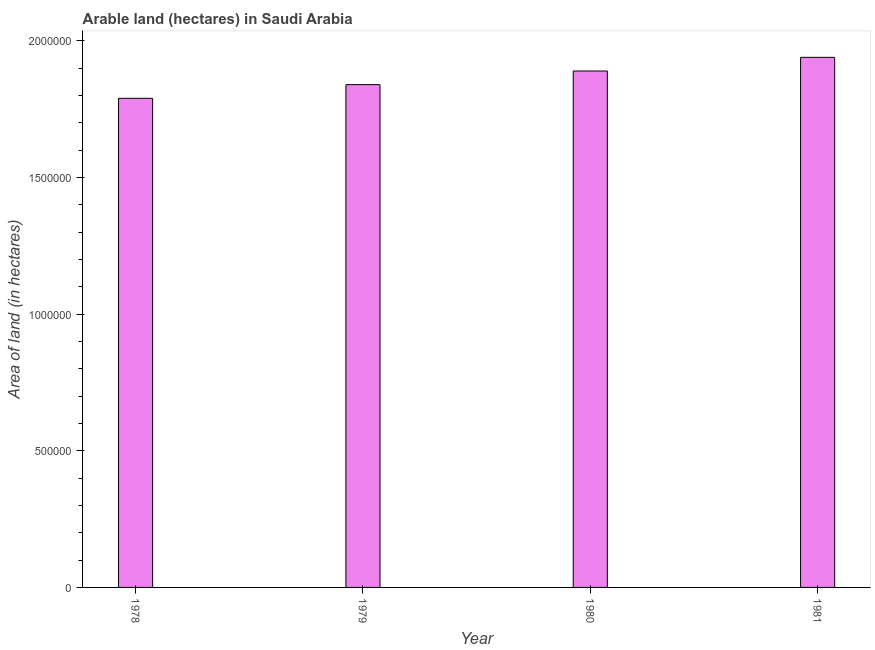Does the graph contain any zero values?
Offer a terse response. No. Does the graph contain grids?
Keep it short and to the point. No. What is the title of the graph?
Your response must be concise. Arable land (hectares) in Saudi Arabia. What is the label or title of the Y-axis?
Ensure brevity in your answer.  Area of land (in hectares). What is the area of land in 1980?
Give a very brief answer. 1.89e+06. Across all years, what is the maximum area of land?
Your answer should be compact. 1.94e+06. Across all years, what is the minimum area of land?
Provide a short and direct response. 1.79e+06. In which year was the area of land minimum?
Offer a terse response. 1978. What is the sum of the area of land?
Offer a terse response. 7.46e+06. What is the average area of land per year?
Offer a very short reply. 1.86e+06. What is the median area of land?
Provide a succinct answer. 1.86e+06. In how many years, is the area of land greater than 1600000 hectares?
Offer a very short reply. 4. Is the area of land in 1978 less than that in 1981?
Make the answer very short. Yes. Is the sum of the area of land in 1978 and 1980 greater than the maximum area of land across all years?
Make the answer very short. Yes. In how many years, is the area of land greater than the average area of land taken over all years?
Offer a very short reply. 2. How many years are there in the graph?
Ensure brevity in your answer.  4. What is the difference between two consecutive major ticks on the Y-axis?
Give a very brief answer. 5.00e+05. Are the values on the major ticks of Y-axis written in scientific E-notation?
Your answer should be very brief. No. What is the Area of land (in hectares) in 1978?
Provide a succinct answer. 1.79e+06. What is the Area of land (in hectares) of 1979?
Provide a short and direct response. 1.84e+06. What is the Area of land (in hectares) of 1980?
Provide a short and direct response. 1.89e+06. What is the Area of land (in hectares) in 1981?
Offer a terse response. 1.94e+06. What is the difference between the Area of land (in hectares) in 1978 and 1979?
Ensure brevity in your answer.  -5.00e+04. What is the difference between the Area of land (in hectares) in 1980 and 1981?
Offer a very short reply. -5.00e+04. What is the ratio of the Area of land (in hectares) in 1978 to that in 1980?
Your answer should be very brief. 0.95. What is the ratio of the Area of land (in hectares) in 1978 to that in 1981?
Keep it short and to the point. 0.92. What is the ratio of the Area of land (in hectares) in 1979 to that in 1980?
Provide a short and direct response. 0.97. What is the ratio of the Area of land (in hectares) in 1979 to that in 1981?
Your response must be concise. 0.95. 